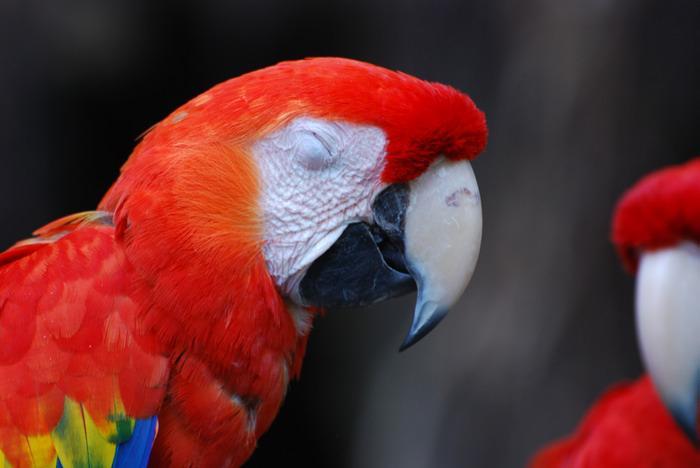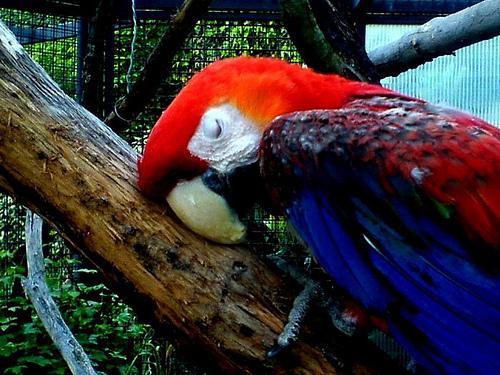The first image is the image on the left, the second image is the image on the right. Examine the images to the left and right. Is the description "The bird in the image on the right has its eyes closed." accurate? Answer yes or no. Yes. The first image is the image on the left, the second image is the image on the right. Given the left and right images, does the statement "Each image shows a red-headed bird with its face in profile and its eye shut." hold true? Answer yes or no. Yes. 